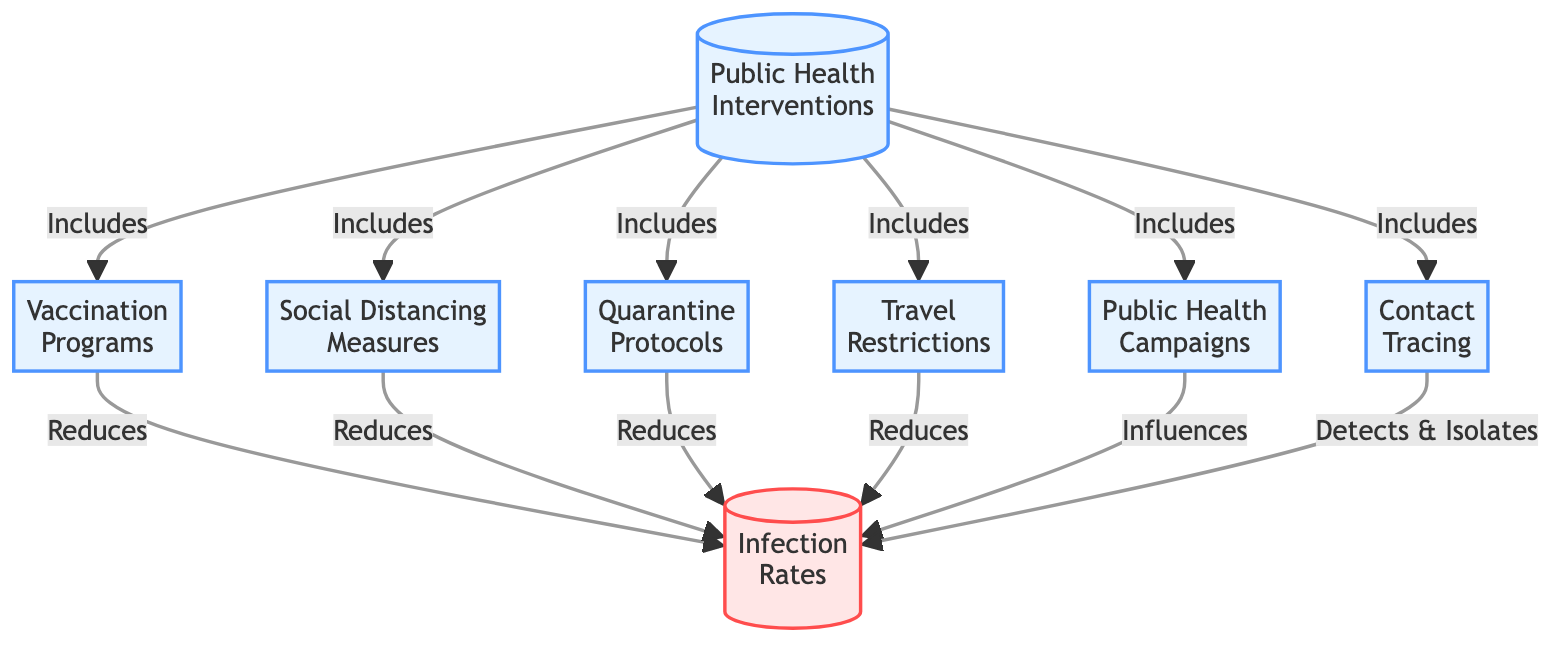What are the public health interventions listed in the diagram? The diagram includes six public health interventions: Vaccination Programs, Social Distancing Measures, Quarantine Protocols, Travel Restrictions, Public Health Campaigns, and Contact Tracing.
Answer: Vaccination Programs, Social Distancing Measures, Quarantine Protocols, Travel Restrictions, Public Health Campaigns, Contact Tracing Which intervention is described as reducing infection rates? The interventions that reduce infection rates are Vaccination Programs, Social Distancing Measures, Quarantine Protocols, and Travel Restrictions.
Answer: Vaccination Programs, Social Distancing Measures, Quarantine Protocols, Travel Restrictions How many interventions are included under public health interventions? The diagram shows a total of six interventions that fall under the category of public health interventions.
Answer: Six What does Contact Tracing do according to the diagram? According to the diagram, Contact Tracing “Detects & Isolates” infections, indicating its role in identifying and managing cases of infection.
Answer: Detects & Isolates Which intervention has an influence rather than directly reducing infection rates? Public Health Campaigns are shown in the diagram as having an influence on infection rates, differing from other interventions that directly reduce them.
Answer: Public Health Campaigns What is the relationship between public health interventions and infection rates? The diagram illustrates that public health interventions generally lead to a reduction in infection rates or influence them.
Answer: Reduces How does Social Distancing impact infection rates? The diagram specifies that Social Distancing Measures directly reduce infection rates, which indicates their effectiveness in controlling outbreaks.
Answer: Reduces How many edges connect the public health interventions to the infection rates? The diagram presents a total of five edges that connect public health interventions to the outcome of infection rates, indicating their relationships.
Answer: Five 